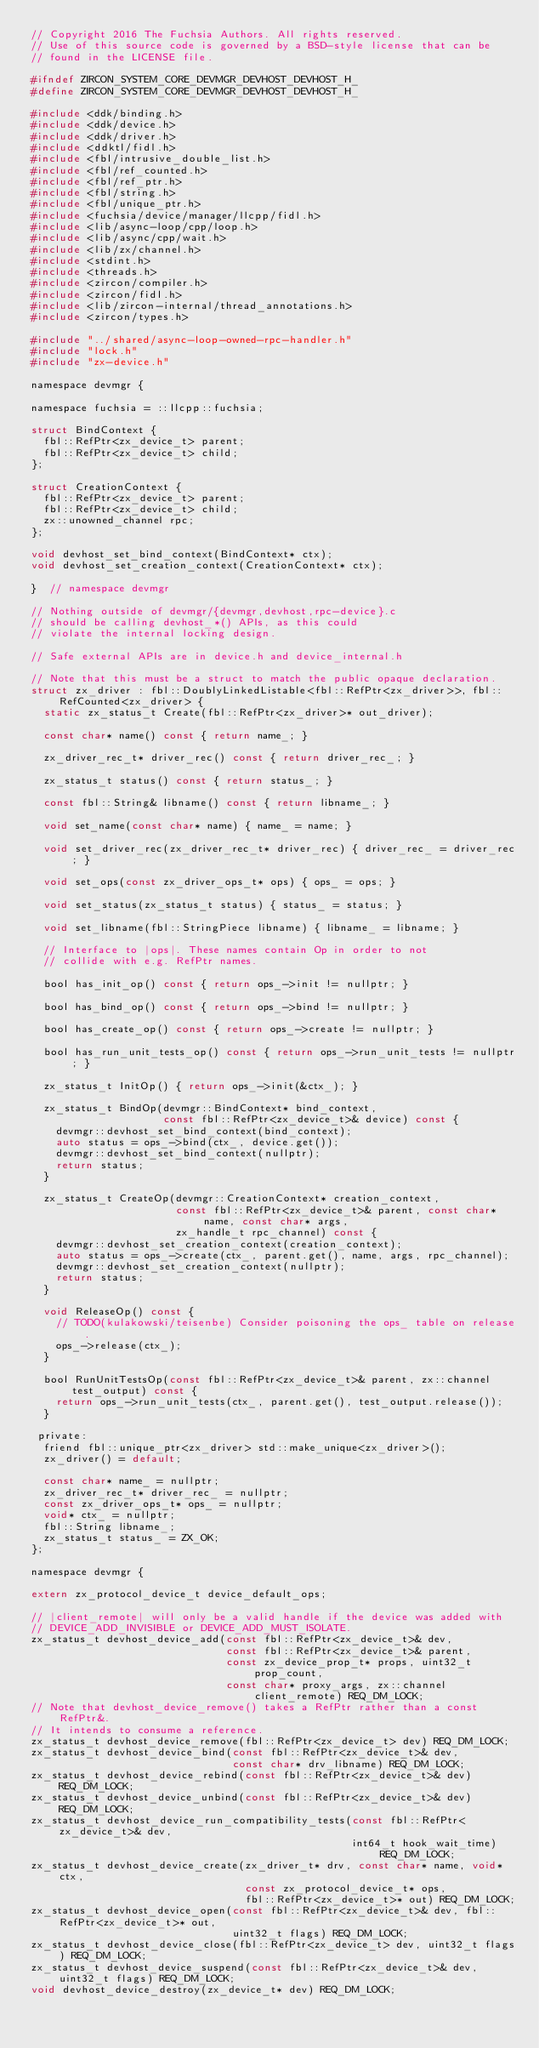Convert code to text. <code><loc_0><loc_0><loc_500><loc_500><_C_>// Copyright 2016 The Fuchsia Authors. All rights reserved.
// Use of this source code is governed by a BSD-style license that can be
// found in the LICENSE file.

#ifndef ZIRCON_SYSTEM_CORE_DEVMGR_DEVHOST_DEVHOST_H_
#define ZIRCON_SYSTEM_CORE_DEVMGR_DEVHOST_DEVHOST_H_

#include <ddk/binding.h>
#include <ddk/device.h>
#include <ddk/driver.h>
#include <ddktl/fidl.h>
#include <fbl/intrusive_double_list.h>
#include <fbl/ref_counted.h>
#include <fbl/ref_ptr.h>
#include <fbl/string.h>
#include <fbl/unique_ptr.h>
#include <fuchsia/device/manager/llcpp/fidl.h>
#include <lib/async-loop/cpp/loop.h>
#include <lib/async/cpp/wait.h>
#include <lib/zx/channel.h>
#include <stdint.h>
#include <threads.h>
#include <zircon/compiler.h>
#include <zircon/fidl.h>
#include <lib/zircon-internal/thread_annotations.h>
#include <zircon/types.h>

#include "../shared/async-loop-owned-rpc-handler.h"
#include "lock.h"
#include "zx-device.h"

namespace devmgr {

namespace fuchsia = ::llcpp::fuchsia;

struct BindContext {
  fbl::RefPtr<zx_device_t> parent;
  fbl::RefPtr<zx_device_t> child;
};

struct CreationContext {
  fbl::RefPtr<zx_device_t> parent;
  fbl::RefPtr<zx_device_t> child;
  zx::unowned_channel rpc;
};

void devhost_set_bind_context(BindContext* ctx);
void devhost_set_creation_context(CreationContext* ctx);

}  // namespace devmgr

// Nothing outside of devmgr/{devmgr,devhost,rpc-device}.c
// should be calling devhost_*() APIs, as this could
// violate the internal locking design.

// Safe external APIs are in device.h and device_internal.h

// Note that this must be a struct to match the public opaque declaration.
struct zx_driver : fbl::DoublyLinkedListable<fbl::RefPtr<zx_driver>>, fbl::RefCounted<zx_driver> {
  static zx_status_t Create(fbl::RefPtr<zx_driver>* out_driver);

  const char* name() const { return name_; }

  zx_driver_rec_t* driver_rec() const { return driver_rec_; }

  zx_status_t status() const { return status_; }

  const fbl::String& libname() const { return libname_; }

  void set_name(const char* name) { name_ = name; }

  void set_driver_rec(zx_driver_rec_t* driver_rec) { driver_rec_ = driver_rec; }

  void set_ops(const zx_driver_ops_t* ops) { ops_ = ops; }

  void set_status(zx_status_t status) { status_ = status; }

  void set_libname(fbl::StringPiece libname) { libname_ = libname; }

  // Interface to |ops|. These names contain Op in order to not
  // collide with e.g. RefPtr names.

  bool has_init_op() const { return ops_->init != nullptr; }

  bool has_bind_op() const { return ops_->bind != nullptr; }

  bool has_create_op() const { return ops_->create != nullptr; }

  bool has_run_unit_tests_op() const { return ops_->run_unit_tests != nullptr; }

  zx_status_t InitOp() { return ops_->init(&ctx_); }

  zx_status_t BindOp(devmgr::BindContext* bind_context,
                     const fbl::RefPtr<zx_device_t>& device) const {
    devmgr::devhost_set_bind_context(bind_context);
    auto status = ops_->bind(ctx_, device.get());
    devmgr::devhost_set_bind_context(nullptr);
    return status;
  }

  zx_status_t CreateOp(devmgr::CreationContext* creation_context,
                       const fbl::RefPtr<zx_device_t>& parent, const char* name, const char* args,
                       zx_handle_t rpc_channel) const {
    devmgr::devhost_set_creation_context(creation_context);
    auto status = ops_->create(ctx_, parent.get(), name, args, rpc_channel);
    devmgr::devhost_set_creation_context(nullptr);
    return status;
  }

  void ReleaseOp() const {
    // TODO(kulakowski/teisenbe) Consider poisoning the ops_ table on release.
    ops_->release(ctx_);
  }

  bool RunUnitTestsOp(const fbl::RefPtr<zx_device_t>& parent, zx::channel test_output) const {
    return ops_->run_unit_tests(ctx_, parent.get(), test_output.release());
  }

 private:
  friend fbl::unique_ptr<zx_driver> std::make_unique<zx_driver>();
  zx_driver() = default;

  const char* name_ = nullptr;
  zx_driver_rec_t* driver_rec_ = nullptr;
  const zx_driver_ops_t* ops_ = nullptr;
  void* ctx_ = nullptr;
  fbl::String libname_;
  zx_status_t status_ = ZX_OK;
};

namespace devmgr {

extern zx_protocol_device_t device_default_ops;

// |client_remote| will only be a valid handle if the device was added with
// DEVICE_ADD_INVISIBLE or DEVICE_ADD_MUST_ISOLATE.
zx_status_t devhost_device_add(const fbl::RefPtr<zx_device_t>& dev,
                               const fbl::RefPtr<zx_device_t>& parent,
                               const zx_device_prop_t* props, uint32_t prop_count,
                               const char* proxy_args, zx::channel client_remote) REQ_DM_LOCK;
// Note that devhost_device_remove() takes a RefPtr rather than a const RefPtr&.
// It intends to consume a reference.
zx_status_t devhost_device_remove(fbl::RefPtr<zx_device_t> dev) REQ_DM_LOCK;
zx_status_t devhost_device_bind(const fbl::RefPtr<zx_device_t>& dev,
                                const char* drv_libname) REQ_DM_LOCK;
zx_status_t devhost_device_rebind(const fbl::RefPtr<zx_device_t>& dev) REQ_DM_LOCK;
zx_status_t devhost_device_unbind(const fbl::RefPtr<zx_device_t>& dev) REQ_DM_LOCK;
zx_status_t devhost_device_run_compatibility_tests(const fbl::RefPtr<zx_device_t>& dev,
                                                   int64_t hook_wait_time) REQ_DM_LOCK;
zx_status_t devhost_device_create(zx_driver_t* drv, const char* name, void* ctx,
                                  const zx_protocol_device_t* ops,
                                  fbl::RefPtr<zx_device_t>* out) REQ_DM_LOCK;
zx_status_t devhost_device_open(const fbl::RefPtr<zx_device_t>& dev, fbl::RefPtr<zx_device_t>* out,
                                uint32_t flags) REQ_DM_LOCK;
zx_status_t devhost_device_close(fbl::RefPtr<zx_device_t> dev, uint32_t flags) REQ_DM_LOCK;
zx_status_t devhost_device_suspend(const fbl::RefPtr<zx_device_t>& dev, uint32_t flags) REQ_DM_LOCK;
void devhost_device_destroy(zx_device_t* dev) REQ_DM_LOCK;
</code> 